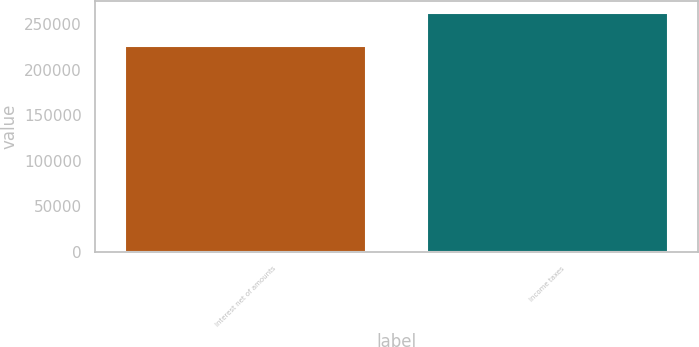<chart> <loc_0><loc_0><loc_500><loc_500><bar_chart><fcel>Interest net of amounts<fcel>Income taxes<nl><fcel>225998<fcel>262504<nl></chart> 